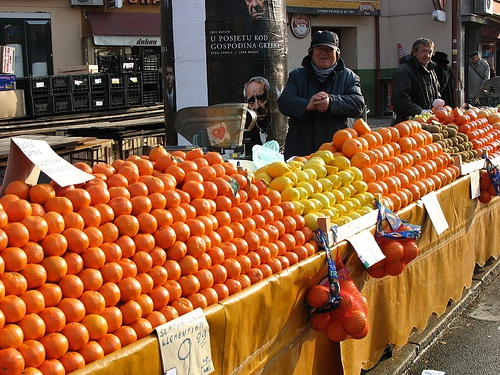Describe the objects in this image and their specific colors. I can see orange in maroon, red, brown, and orange tones, people in maroon, black, gray, and darkgray tones, orange in maroon, red, tan, and ivory tones, people in maroon, black, gray, and darkgray tones, and people in maroon, black, and gray tones in this image. 